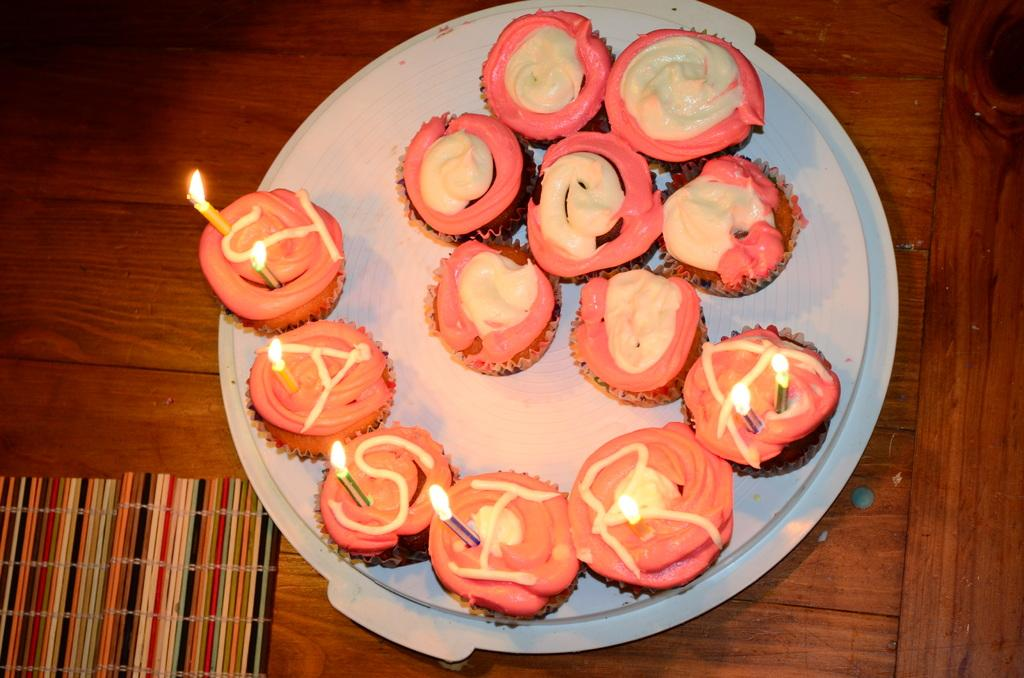What type of dessert can be seen on the plate in the image? There are cupcakes on a plate in the image. Where is the plate with cupcakes located? The plate is placed on a table. What additional decorations are on the cupcakes? There are candles on the cupcakes. What type of army maneuver is being performed by the cupcakes in the image? There is no army or maneuver present in the image; it features cupcakes with candles on a plate. 